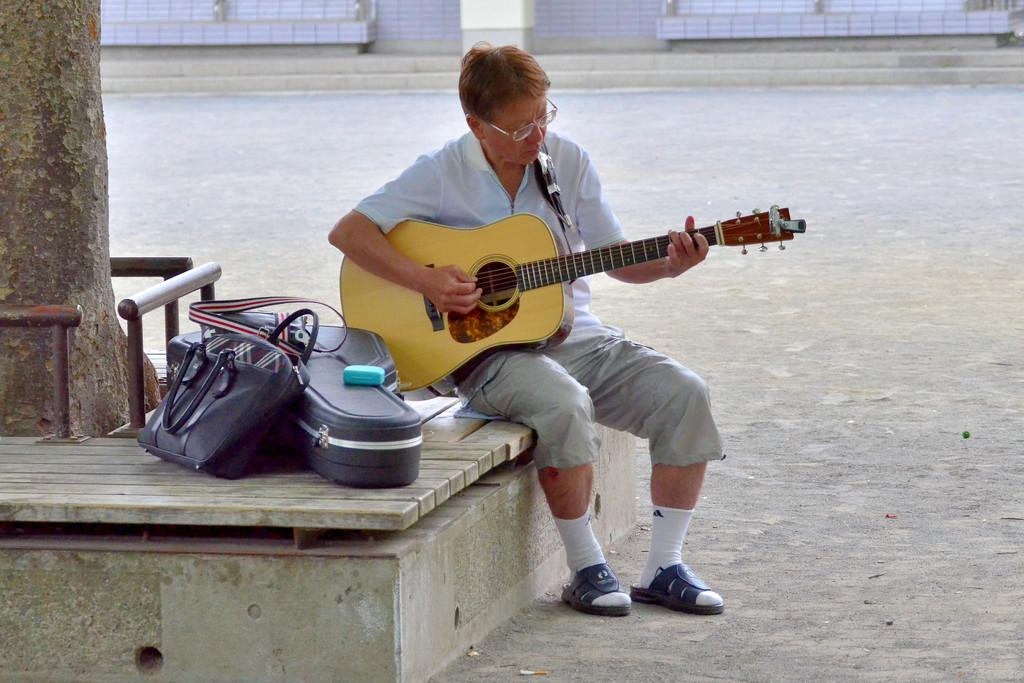What is the man in the image doing? The man is playing a guitar in the image. What is the man wearing in the image? The man is wearing a white shirt, trousers, and sandals in the image. What objects are present in the image besides the man and his guitar? There is a guitar box and a handbag in the image. What can be seen in the background of the image? There is a tree in the image. What type of scissors can be seen cutting the tomatoes in the image? There are no scissors or tomatoes present in the image. Can you tell me how many ants are crawling on the man's hand in the image? There are no ants visible on the man's hand or anywhere else in the image. 